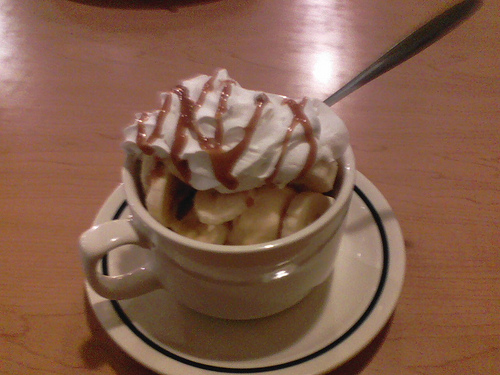<image>
Is there a spoon to the right of the plate? Yes. From this viewpoint, the spoon is positioned to the right side relative to the plate. Is the banana on the table? Yes. Looking at the image, I can see the banana is positioned on top of the table, with the table providing support. 